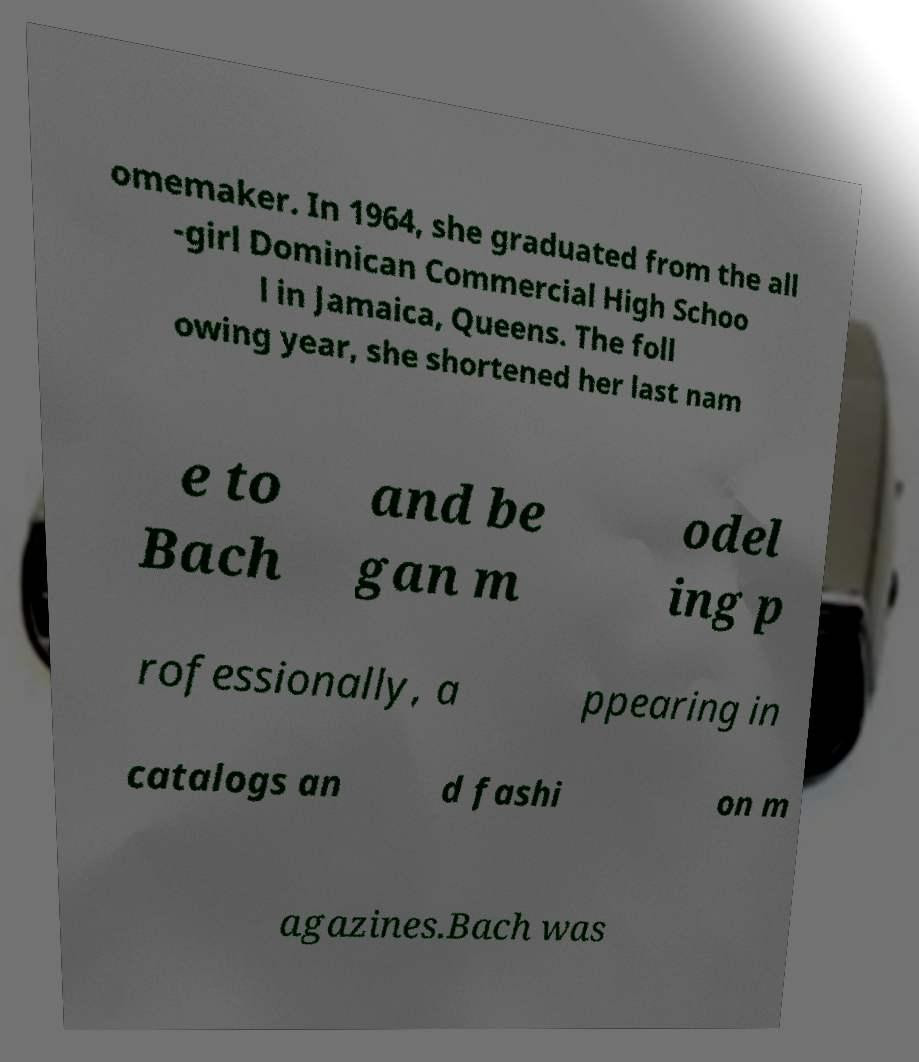Could you assist in decoding the text presented in this image and type it out clearly? omemaker. In 1964, she graduated from the all -girl Dominican Commercial High Schoo l in Jamaica, Queens. The foll owing year, she shortened her last nam e to Bach and be gan m odel ing p rofessionally, a ppearing in catalogs an d fashi on m agazines.Bach was 